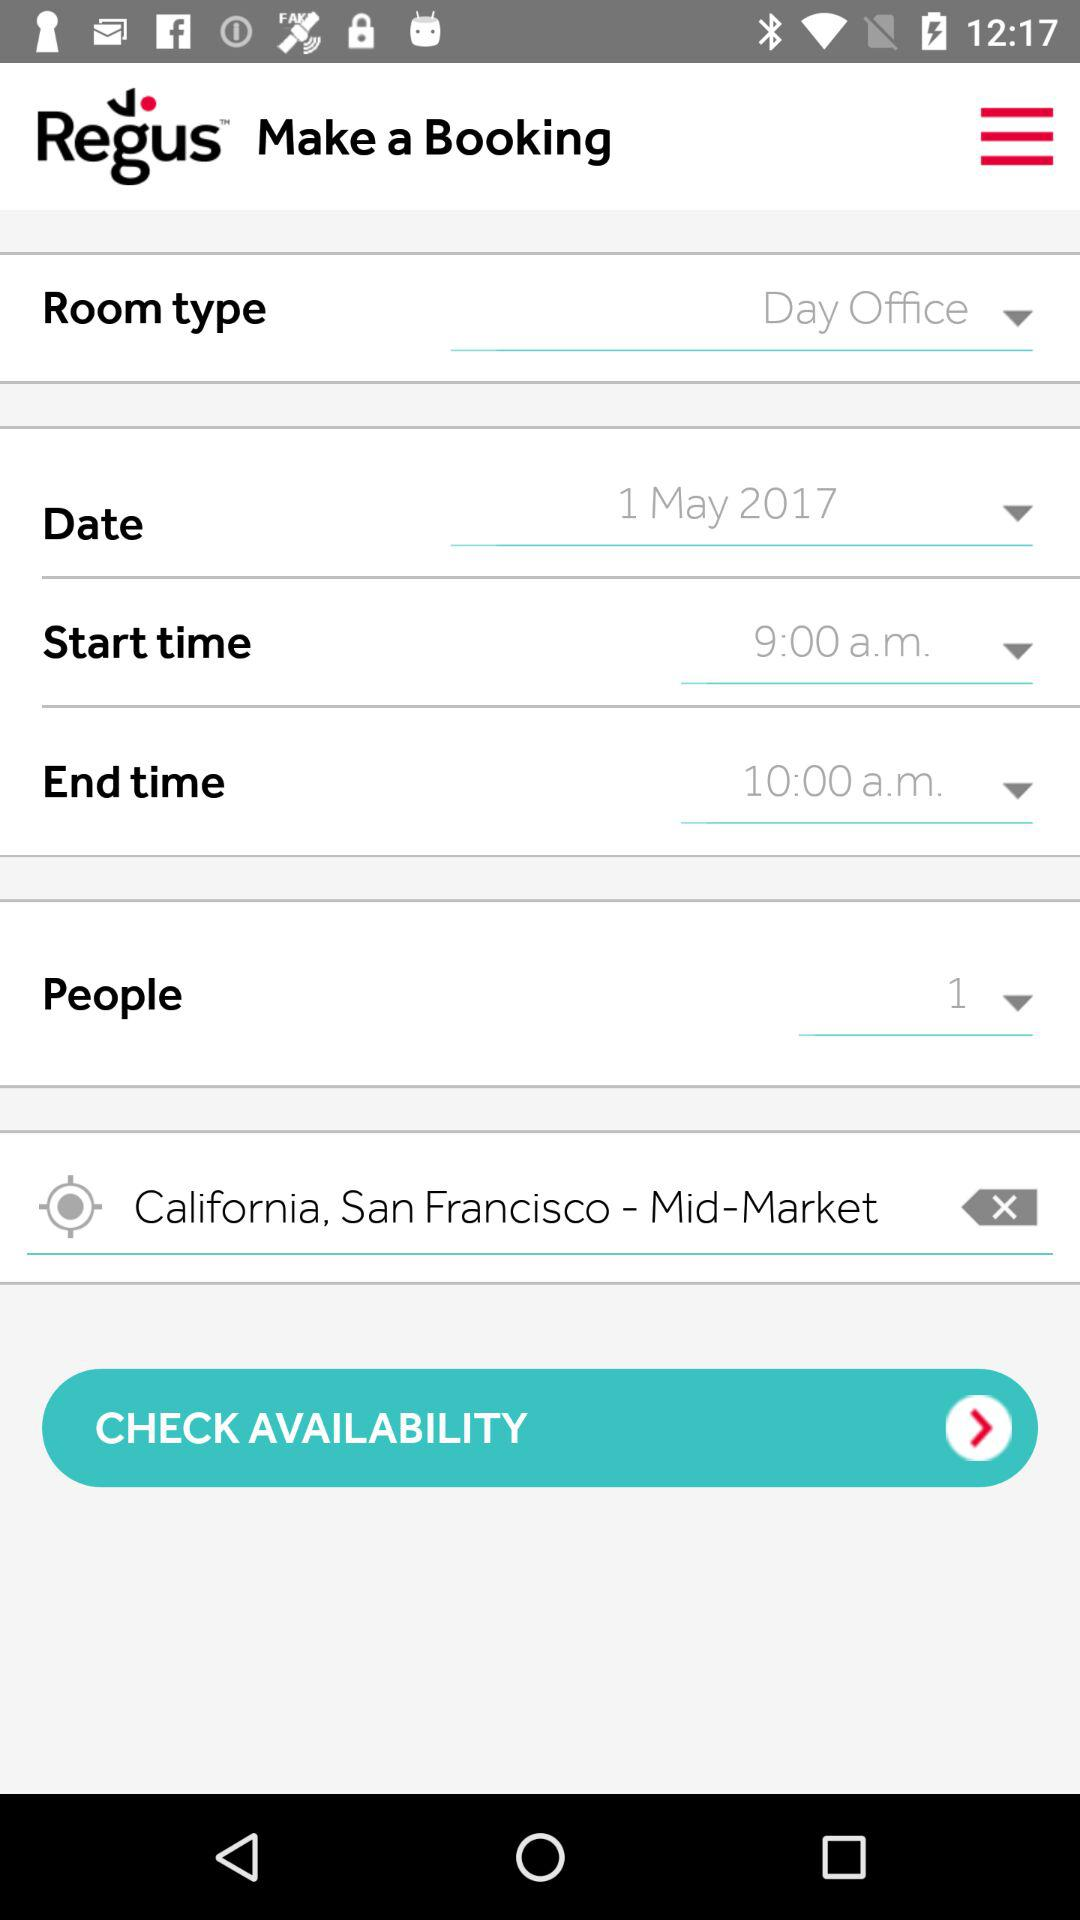Which room type is selected? The selected room type is "Day Office". 